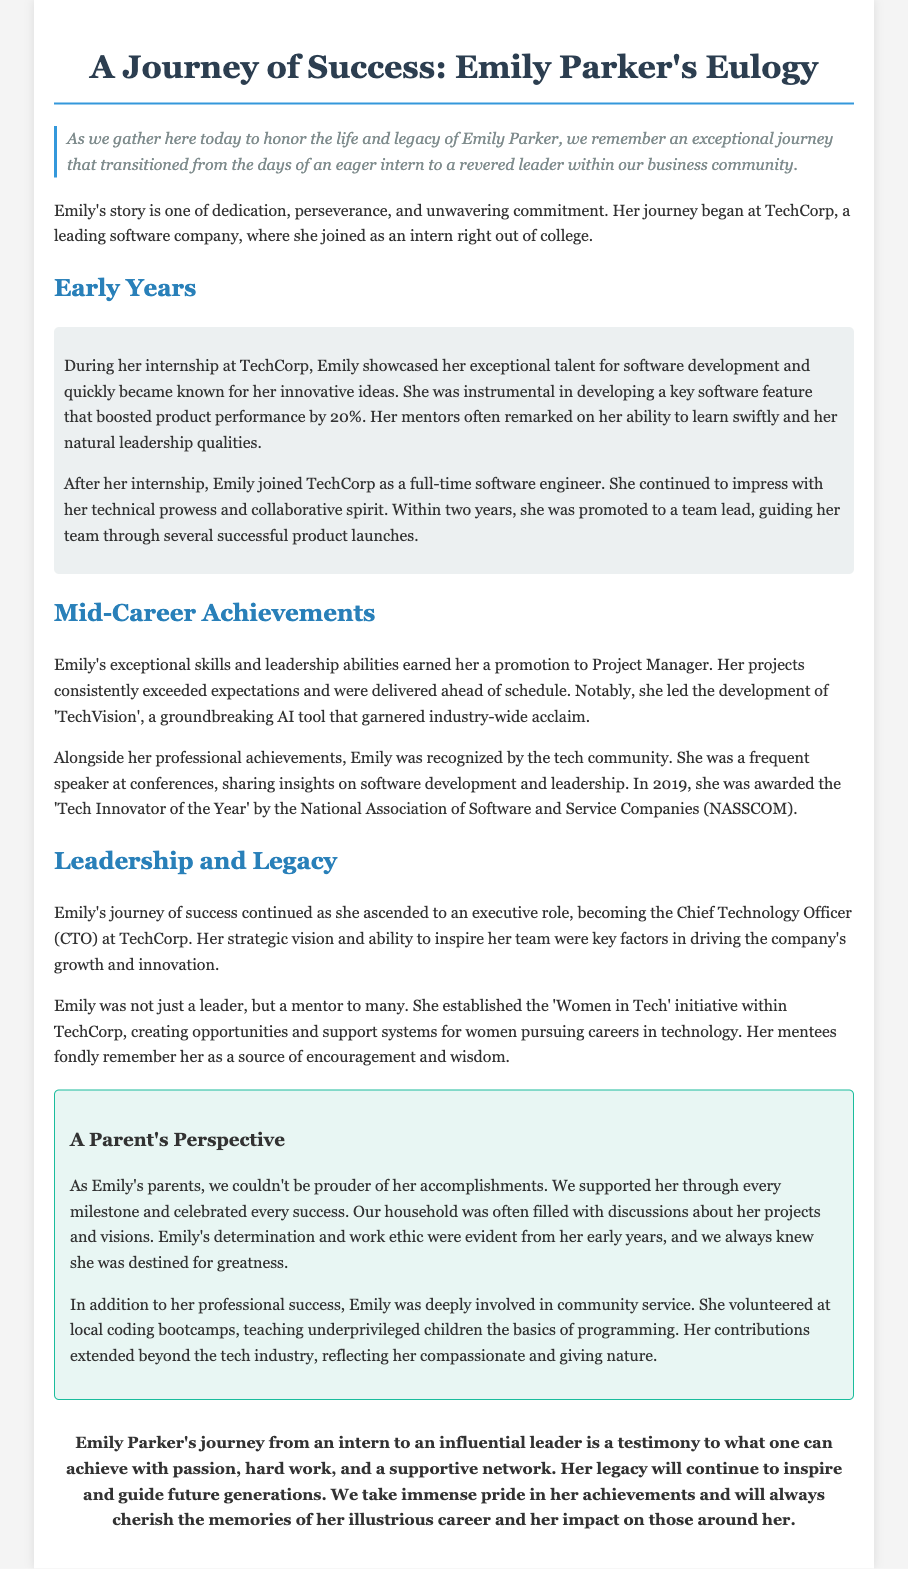what was Emily Parker's first role at TechCorp? Emily started her journey as an intern right out of college at TechCorp.
Answer: intern what percentage did Emily's software feature boost product performance? The document states that Emily developed a key software feature that boosted product performance by 20%.
Answer: 20% what award did Emily receive in 2019? The document mentions that she was awarded the 'Tech Innovator of the Year' by NASSCOM in 2019.
Answer: Tech Innovator of the Year what initiative did Emily establish at TechCorp? She established the 'Women in Tech' initiative to support women in technology careers.
Answer: Women in Tech how long was Emily at TechCorp before becoming a team lead? Emily was promoted to a team lead within two years after her internship.
Answer: two years what was a significant project led by Emily during her career? The development of 'TechVision', a groundbreaking AI tool that garnered industry-wide acclaim, was a notable project she led.
Answer: TechVision how did Emily contribute to the community? Emily volunteered at local coding bootcamps, teaching underprivileged children programming basics.
Answer: volunteering what qualities did Emily's mentors attribute to her during her internship? Her mentors remarked on her exceptional talent, ability to learn swiftly, and natural leadership qualities.
Answer: talent and leadership qualities what is the main theme of the eulogy? The eulogy reflects on Emily's journey from intern to an influential leader, showcasing her dedication and impact.
Answer: journey of success 